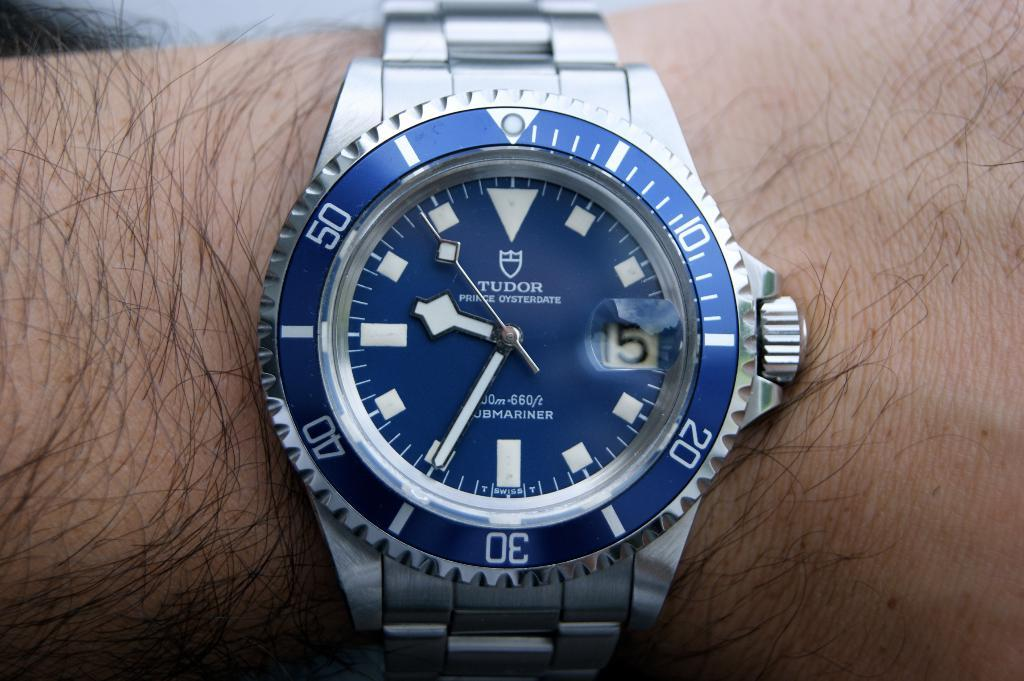<image>
Present a compact description of the photo's key features. A silver Tudor brand watch with a blue face and blue dial. 